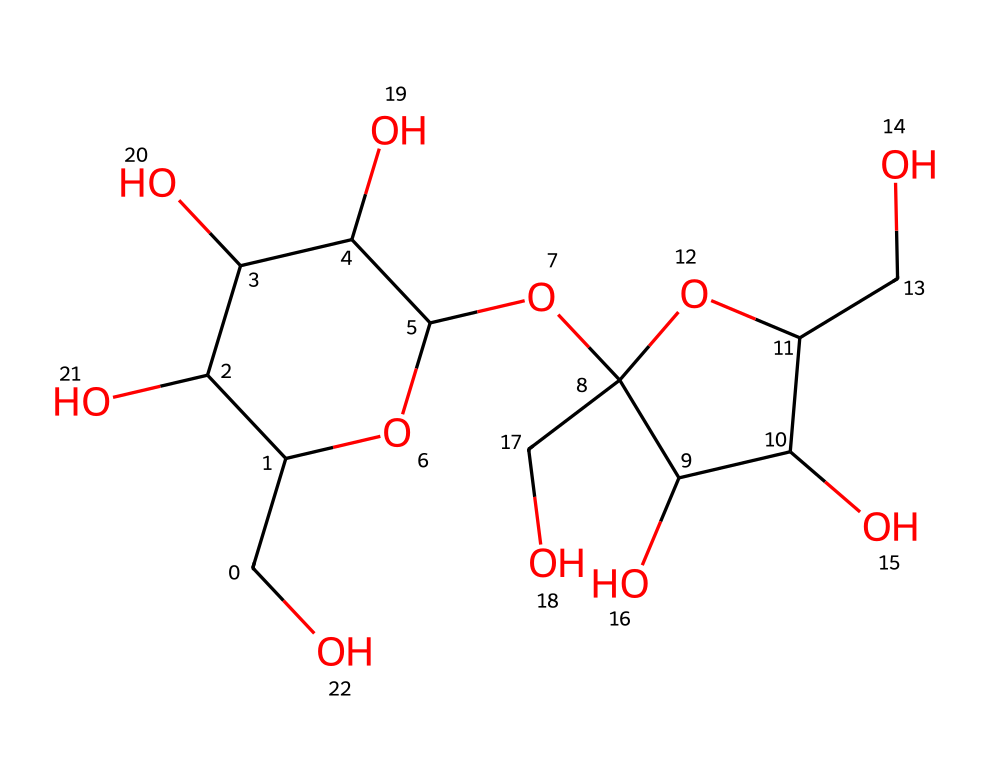What is the molecular formula of sucrose? To derive the molecular formula from the SMILES representation, count each type of atom present in the structure. The structure contains 12 carbon (C), 22 hydrogen (H), and 11 oxygen (O) atoms. Thus, the molecular formula is C12H22O11.
Answer: C12H22O11 How many glycosidic bonds are present in sucrose? By analyzing the structure in the SMILES, we note that sucrose is composed of two monosaccharides joined by one glycosidic bond between the glucose and fructose components. Therefore, there is one glycosidic bond.
Answer: 1 What type of glycosidic bond is found in sucrose? Sucrose consists of a bond that is formed between the glucose (which is in the alpha configuration) and fructose (which is in the beta configuration), resulting in an α(1→2) glycosidic bond.
Answer: α(1→2) How many hydroxyl groups are in sucrose? Count the number of hydroxyl (–OH) groups in the SMILES representation. There are 5 distinct hydroxyl groups present in the structure of sucrose.
Answer: 5 Which monosaccharides make up sucrose? By examining the structure, it can be seen that sucrose is composed of glucose and fructose. Thus, the monosaccharides are identified as glucose and fructose.
Answer: glucose and fructose What is the primary function of sucrose in plants? Sucrose serves primarily as a carbohydrate that provides energy and acts as a transport sugar, moving energy from photosynthesis to other parts of the plant.
Answer: energy transport 